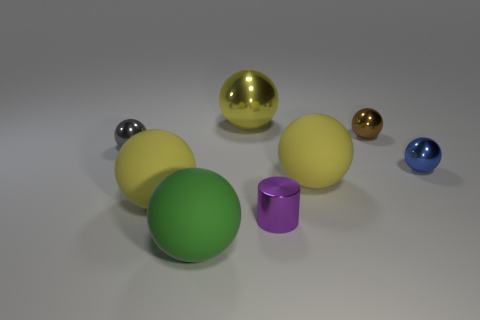Subtract all cyan cubes. How many yellow spheres are left? 3 Subtract all yellow balls. How many balls are left? 4 Subtract all small gray balls. How many balls are left? 6 Subtract 3 balls. How many balls are left? 4 Subtract all gray spheres. Subtract all blue cubes. How many spheres are left? 6 Add 1 rubber spheres. How many objects exist? 9 Subtract all spheres. How many objects are left? 1 Add 3 yellow shiny spheres. How many yellow shiny spheres are left? 4 Add 2 tiny gray metal things. How many tiny gray metal things exist? 3 Subtract 1 blue balls. How many objects are left? 7 